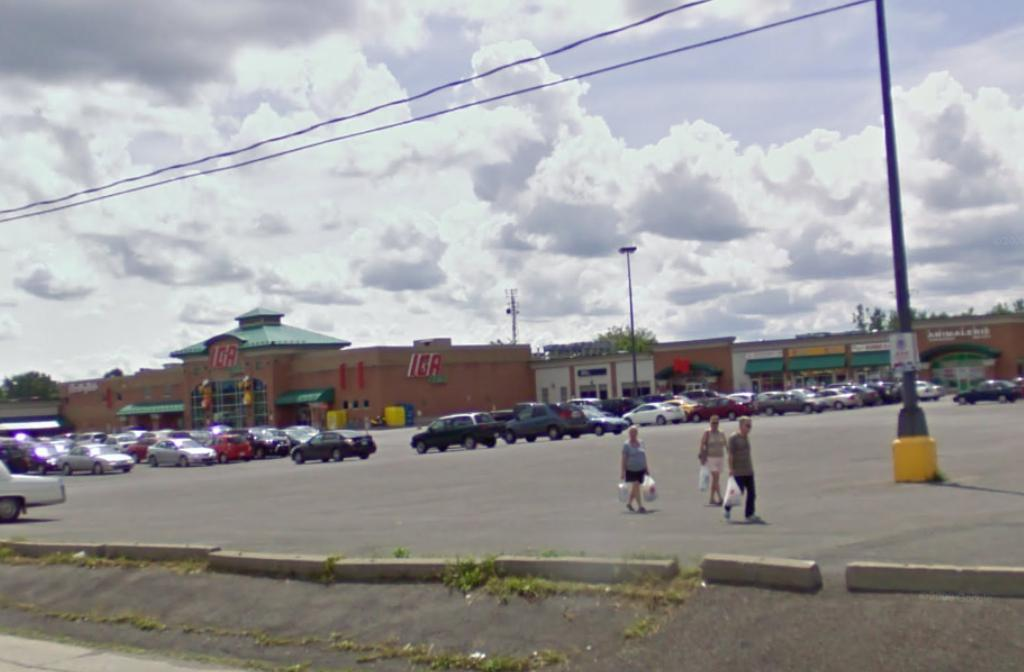<image>
Write a terse but informative summary of the picture. a parking lot in front of an IGA store 